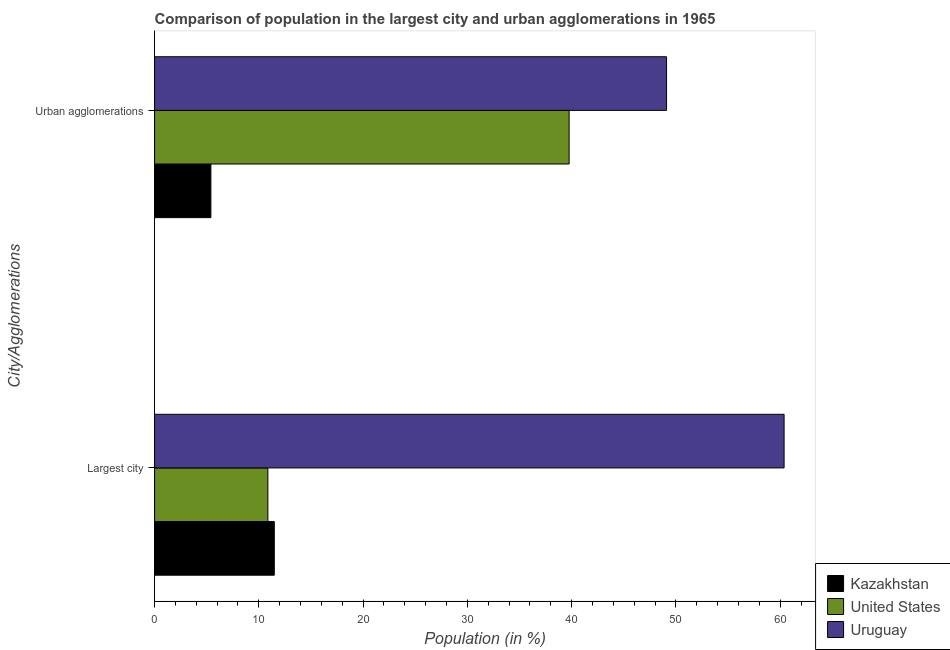How many different coloured bars are there?
Give a very brief answer. 3. How many groups of bars are there?
Give a very brief answer. 2. Are the number of bars on each tick of the Y-axis equal?
Make the answer very short. Yes. What is the label of the 1st group of bars from the top?
Your answer should be very brief. Urban agglomerations. What is the population in the largest city in United States?
Give a very brief answer. 10.87. Across all countries, what is the maximum population in urban agglomerations?
Provide a succinct answer. 49.1. Across all countries, what is the minimum population in urban agglomerations?
Give a very brief answer. 5.4. In which country was the population in urban agglomerations maximum?
Offer a very short reply. Uruguay. What is the total population in the largest city in the graph?
Keep it short and to the point. 82.72. What is the difference between the population in the largest city in Uruguay and that in United States?
Provide a short and direct response. 49.51. What is the difference between the population in urban agglomerations in United States and the population in the largest city in Kazakhstan?
Offer a very short reply. 28.28. What is the average population in urban agglomerations per country?
Provide a short and direct response. 31.42. What is the difference between the population in the largest city and population in urban agglomerations in Uruguay?
Your answer should be compact. 11.27. In how many countries, is the population in the largest city greater than 2 %?
Give a very brief answer. 3. What is the ratio of the population in the largest city in United States to that in Uruguay?
Keep it short and to the point. 0.18. In how many countries, is the population in urban agglomerations greater than the average population in urban agglomerations taken over all countries?
Your response must be concise. 2. What does the 3rd bar from the bottom in Largest city represents?
Offer a very short reply. Uruguay. How many countries are there in the graph?
Your response must be concise. 3. What is the difference between two consecutive major ticks on the X-axis?
Provide a succinct answer. 10. Does the graph contain any zero values?
Give a very brief answer. No. Does the graph contain grids?
Provide a succinct answer. No. How many legend labels are there?
Give a very brief answer. 3. How are the legend labels stacked?
Your response must be concise. Vertical. What is the title of the graph?
Give a very brief answer. Comparison of population in the largest city and urban agglomerations in 1965. What is the label or title of the Y-axis?
Your answer should be compact. City/Agglomerations. What is the Population (in %) in Kazakhstan in Largest city?
Give a very brief answer. 11.48. What is the Population (in %) of United States in Largest city?
Ensure brevity in your answer.  10.87. What is the Population (in %) of Uruguay in Largest city?
Make the answer very short. 60.37. What is the Population (in %) of Kazakhstan in Urban agglomerations?
Keep it short and to the point. 5.4. What is the Population (in %) in United States in Urban agglomerations?
Your answer should be compact. 39.76. What is the Population (in %) in Uruguay in Urban agglomerations?
Provide a short and direct response. 49.1. Across all City/Agglomerations, what is the maximum Population (in %) of Kazakhstan?
Your answer should be compact. 11.48. Across all City/Agglomerations, what is the maximum Population (in %) of United States?
Provide a succinct answer. 39.76. Across all City/Agglomerations, what is the maximum Population (in %) in Uruguay?
Provide a succinct answer. 60.37. Across all City/Agglomerations, what is the minimum Population (in %) of Kazakhstan?
Your response must be concise. 5.4. Across all City/Agglomerations, what is the minimum Population (in %) of United States?
Offer a terse response. 10.87. Across all City/Agglomerations, what is the minimum Population (in %) in Uruguay?
Your response must be concise. 49.1. What is the total Population (in %) in Kazakhstan in the graph?
Offer a very short reply. 16.88. What is the total Population (in %) of United States in the graph?
Offer a very short reply. 50.63. What is the total Population (in %) in Uruguay in the graph?
Ensure brevity in your answer.  109.48. What is the difference between the Population (in %) in Kazakhstan in Largest city and that in Urban agglomerations?
Your answer should be very brief. 6.08. What is the difference between the Population (in %) of United States in Largest city and that in Urban agglomerations?
Your response must be concise. -28.89. What is the difference between the Population (in %) in Uruguay in Largest city and that in Urban agglomerations?
Provide a short and direct response. 11.27. What is the difference between the Population (in %) in Kazakhstan in Largest city and the Population (in %) in United States in Urban agglomerations?
Ensure brevity in your answer.  -28.28. What is the difference between the Population (in %) of Kazakhstan in Largest city and the Population (in %) of Uruguay in Urban agglomerations?
Ensure brevity in your answer.  -37.62. What is the difference between the Population (in %) in United States in Largest city and the Population (in %) in Uruguay in Urban agglomerations?
Your answer should be compact. -38.23. What is the average Population (in %) of Kazakhstan per City/Agglomerations?
Provide a short and direct response. 8.44. What is the average Population (in %) of United States per City/Agglomerations?
Your response must be concise. 25.31. What is the average Population (in %) of Uruguay per City/Agglomerations?
Make the answer very short. 54.74. What is the difference between the Population (in %) in Kazakhstan and Population (in %) in United States in Largest city?
Offer a very short reply. 0.62. What is the difference between the Population (in %) in Kazakhstan and Population (in %) in Uruguay in Largest city?
Give a very brief answer. -48.89. What is the difference between the Population (in %) in United States and Population (in %) in Uruguay in Largest city?
Offer a very short reply. -49.51. What is the difference between the Population (in %) in Kazakhstan and Population (in %) in United States in Urban agglomerations?
Offer a terse response. -34.36. What is the difference between the Population (in %) of Kazakhstan and Population (in %) of Uruguay in Urban agglomerations?
Make the answer very short. -43.7. What is the difference between the Population (in %) of United States and Population (in %) of Uruguay in Urban agglomerations?
Offer a terse response. -9.34. What is the ratio of the Population (in %) of Kazakhstan in Largest city to that in Urban agglomerations?
Offer a very short reply. 2.13. What is the ratio of the Population (in %) in United States in Largest city to that in Urban agglomerations?
Provide a short and direct response. 0.27. What is the ratio of the Population (in %) in Uruguay in Largest city to that in Urban agglomerations?
Provide a succinct answer. 1.23. What is the difference between the highest and the second highest Population (in %) of Kazakhstan?
Your answer should be compact. 6.08. What is the difference between the highest and the second highest Population (in %) of United States?
Offer a very short reply. 28.89. What is the difference between the highest and the second highest Population (in %) of Uruguay?
Keep it short and to the point. 11.27. What is the difference between the highest and the lowest Population (in %) of Kazakhstan?
Your response must be concise. 6.08. What is the difference between the highest and the lowest Population (in %) in United States?
Ensure brevity in your answer.  28.89. What is the difference between the highest and the lowest Population (in %) of Uruguay?
Your answer should be compact. 11.27. 